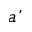<formula> <loc_0><loc_0><loc_500><loc_500>\acute { a }</formula> 